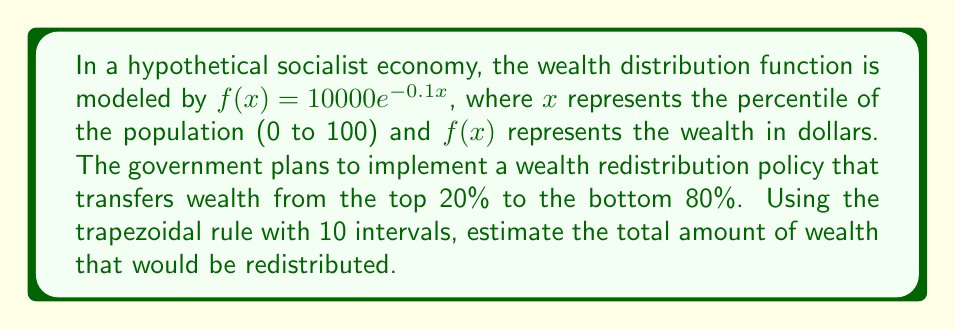Help me with this question. 1) First, we need to set up the integral to calculate the wealth of the top 20%:

   $$\int_{80}^{100} 10000e^{-0.1x} dx$$

2) We'll use the trapezoidal rule with 10 intervals. The step size h is:

   $$h = \frac{100 - 80}{10} = 2$$

3) The trapezoidal rule formula is:

   $$\int_{a}^{b} f(x) dx \approx \frac{h}{2}[f(x_0) + 2f(x_1) + 2f(x_2) + ... + 2f(x_{n-1}) + f(x_n)]$$

4) Calculate the function values:

   $f(80) = 10000e^{-8} \approx 33.55$
   $f(82) = 10000e^{-8.2} \approx 27.39$
   $f(84) = 10000e^{-8.4} \approx 22.36$
   $f(86) = 10000e^{-8.6} \approx 18.26$
   $f(88) = 10000e^{-8.8} \approx 14.91$
   $f(90) = 10000e^{-9} \approx 12.18$
   $f(92) = 10000e^{-9.2} \approx 9.95$
   $f(94) = 10000e^{-9.4} \approx 8.12$
   $f(96) = 10000e^{-9.6} \approx 6.63$
   $f(98) = 10000e^{-9.8} \approx 5.42$
   $f(100) = 10000e^{-10} \approx 4.42$

5) Apply the trapezoidal rule:

   $$\text{Wealth} \approx \frac{2}{2}[33.55 + 2(27.39 + 22.36 + 18.26 + 14.91 + 12.18 + 9.95 + 8.12 + 6.63 + 5.42) + 4.42]$$

6) Simplify:

   $$\text{Wealth} \approx 33.55 + 250.44 + 4.42 = 288.41$$

Therefore, the estimated amount of wealth to be redistributed is approximately $288.41.
Answer: $288.41 